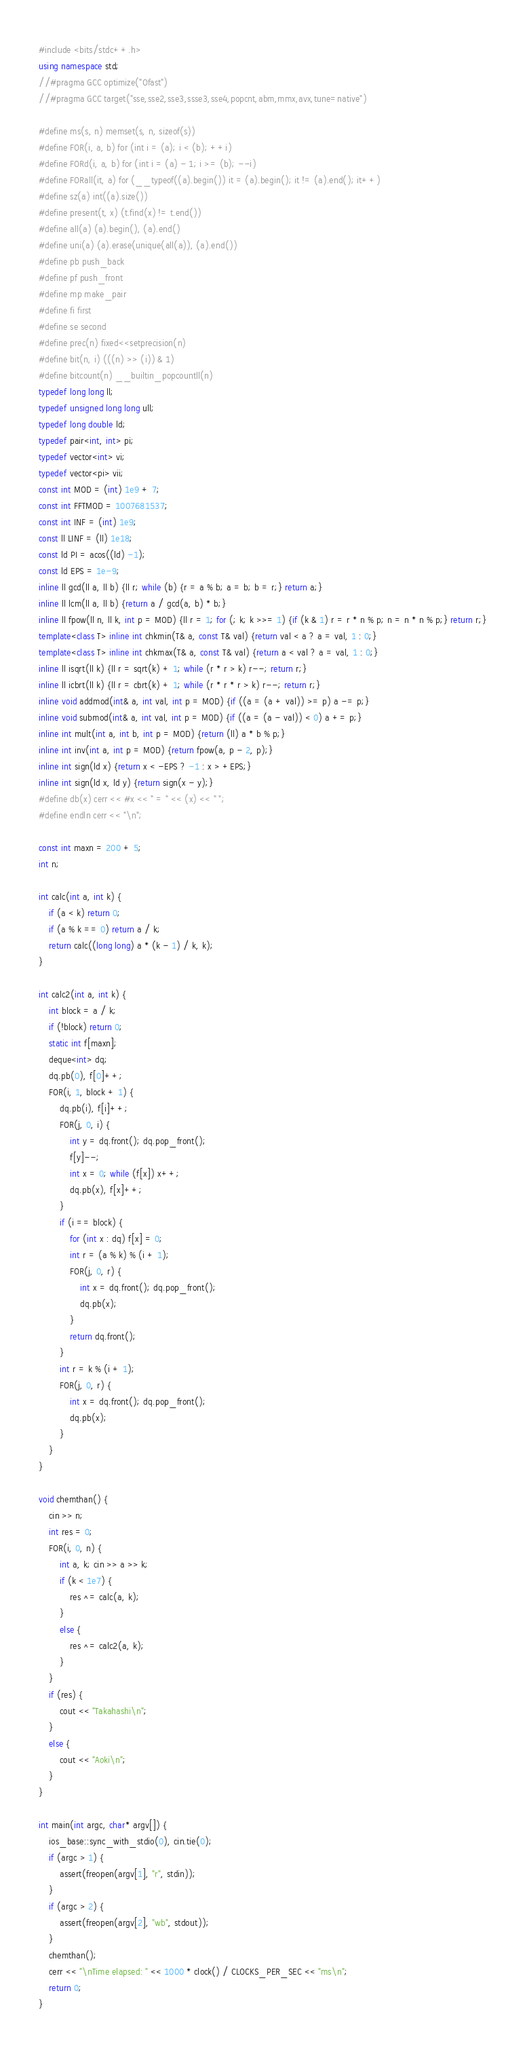<code> <loc_0><loc_0><loc_500><loc_500><_C++_>#include <bits/stdc++.h>
using namespace std;
//#pragma GCC optimize("Ofast")
//#pragma GCC target("sse,sse2,sse3,ssse3,sse4,popcnt,abm,mmx,avx,tune=native")

#define ms(s, n) memset(s, n, sizeof(s))
#define FOR(i, a, b) for (int i = (a); i < (b); ++i)
#define FORd(i, a, b) for (int i = (a) - 1; i >= (b); --i)
#define FORall(it, a) for (__typeof((a).begin()) it = (a).begin(); it != (a).end(); it++)
#define sz(a) int((a).size())
#define present(t, x) (t.find(x) != t.end())
#define all(a) (a).begin(), (a).end()
#define uni(a) (a).erase(unique(all(a)), (a).end())
#define pb push_back
#define pf push_front
#define mp make_pair
#define fi first
#define se second
#define prec(n) fixed<<setprecision(n)
#define bit(n, i) (((n) >> (i)) & 1)
#define bitcount(n) __builtin_popcountll(n)
typedef long long ll;
typedef unsigned long long ull;
typedef long double ld;
typedef pair<int, int> pi;
typedef vector<int> vi;
typedef vector<pi> vii;
const int MOD = (int) 1e9 + 7;
const int FFTMOD = 1007681537;
const int INF = (int) 1e9;
const ll LINF = (ll) 1e18;
const ld PI = acos((ld) -1);
const ld EPS = 1e-9;
inline ll gcd(ll a, ll b) {ll r; while (b) {r = a % b; a = b; b = r;} return a;}
inline ll lcm(ll a, ll b) {return a / gcd(a, b) * b;}
inline ll fpow(ll n, ll k, int p = MOD) {ll r = 1; for (; k; k >>= 1) {if (k & 1) r = r * n % p; n = n * n % p;} return r;}
template<class T> inline int chkmin(T& a, const T& val) {return val < a ? a = val, 1 : 0;}
template<class T> inline int chkmax(T& a, const T& val) {return a < val ? a = val, 1 : 0;}
inline ll isqrt(ll k) {ll r = sqrt(k) + 1; while (r * r > k) r--; return r;}
inline ll icbrt(ll k) {ll r = cbrt(k) + 1; while (r * r * r > k) r--; return r;}
inline void addmod(int& a, int val, int p = MOD) {if ((a = (a + val)) >= p) a -= p;}
inline void submod(int& a, int val, int p = MOD) {if ((a = (a - val)) < 0) a += p;}
inline int mult(int a, int b, int p = MOD) {return (ll) a * b % p;}
inline int inv(int a, int p = MOD) {return fpow(a, p - 2, p);}
inline int sign(ld x) {return x < -EPS ? -1 : x > +EPS;}
inline int sign(ld x, ld y) {return sign(x - y);}
#define db(x) cerr << #x << " = " << (x) << " ";
#define endln cerr << "\n";

const int maxn = 200 + 5;
int n;

int calc(int a, int k) {
    if (a < k) return 0;
    if (a % k == 0) return a / k;
    return calc((long long) a * (k - 1) / k, k);
}

int calc2(int a, int k) {
    int block = a / k;
    if (!block) return 0;
    static int f[maxn];
    deque<int> dq;
    dq.pb(0), f[0]++;
    FOR(i, 1, block + 1) {
        dq.pb(i), f[i]++;
        FOR(j, 0, i) {
            int y = dq.front(); dq.pop_front();
            f[y]--;
            int x = 0; while (f[x]) x++;
            dq.pb(x), f[x]++;
        }
        if (i == block) {
            for (int x : dq) f[x] = 0;
            int r = (a % k) % (i + 1);
            FOR(j, 0, r) {
                int x = dq.front(); dq.pop_front();
                dq.pb(x);
            }
            return dq.front();
        }
        int r = k % (i + 1);
        FOR(j, 0, r) {
            int x = dq.front(); dq.pop_front();
            dq.pb(x);
        }
    }
}

void chemthan() {
    cin >> n;
    int res = 0;
    FOR(i, 0, n) {
        int a, k; cin >> a >> k;
        if (k < 1e7) {
            res ^= calc(a, k);
        }
        else {
            res ^= calc2(a, k);
        }
    }
    if (res) {
        cout << "Takahashi\n";
    }
    else {
        cout << "Aoki\n";
    }
}

int main(int argc, char* argv[]) {
    ios_base::sync_with_stdio(0), cin.tie(0);
    if (argc > 1) {
        assert(freopen(argv[1], "r", stdin));
    }
    if (argc > 2) {
        assert(freopen(argv[2], "wb", stdout));
    }
    chemthan();
    cerr << "\nTime elapsed: " << 1000 * clock() / CLOCKS_PER_SEC << "ms\n";
    return 0;
} 
</code> 